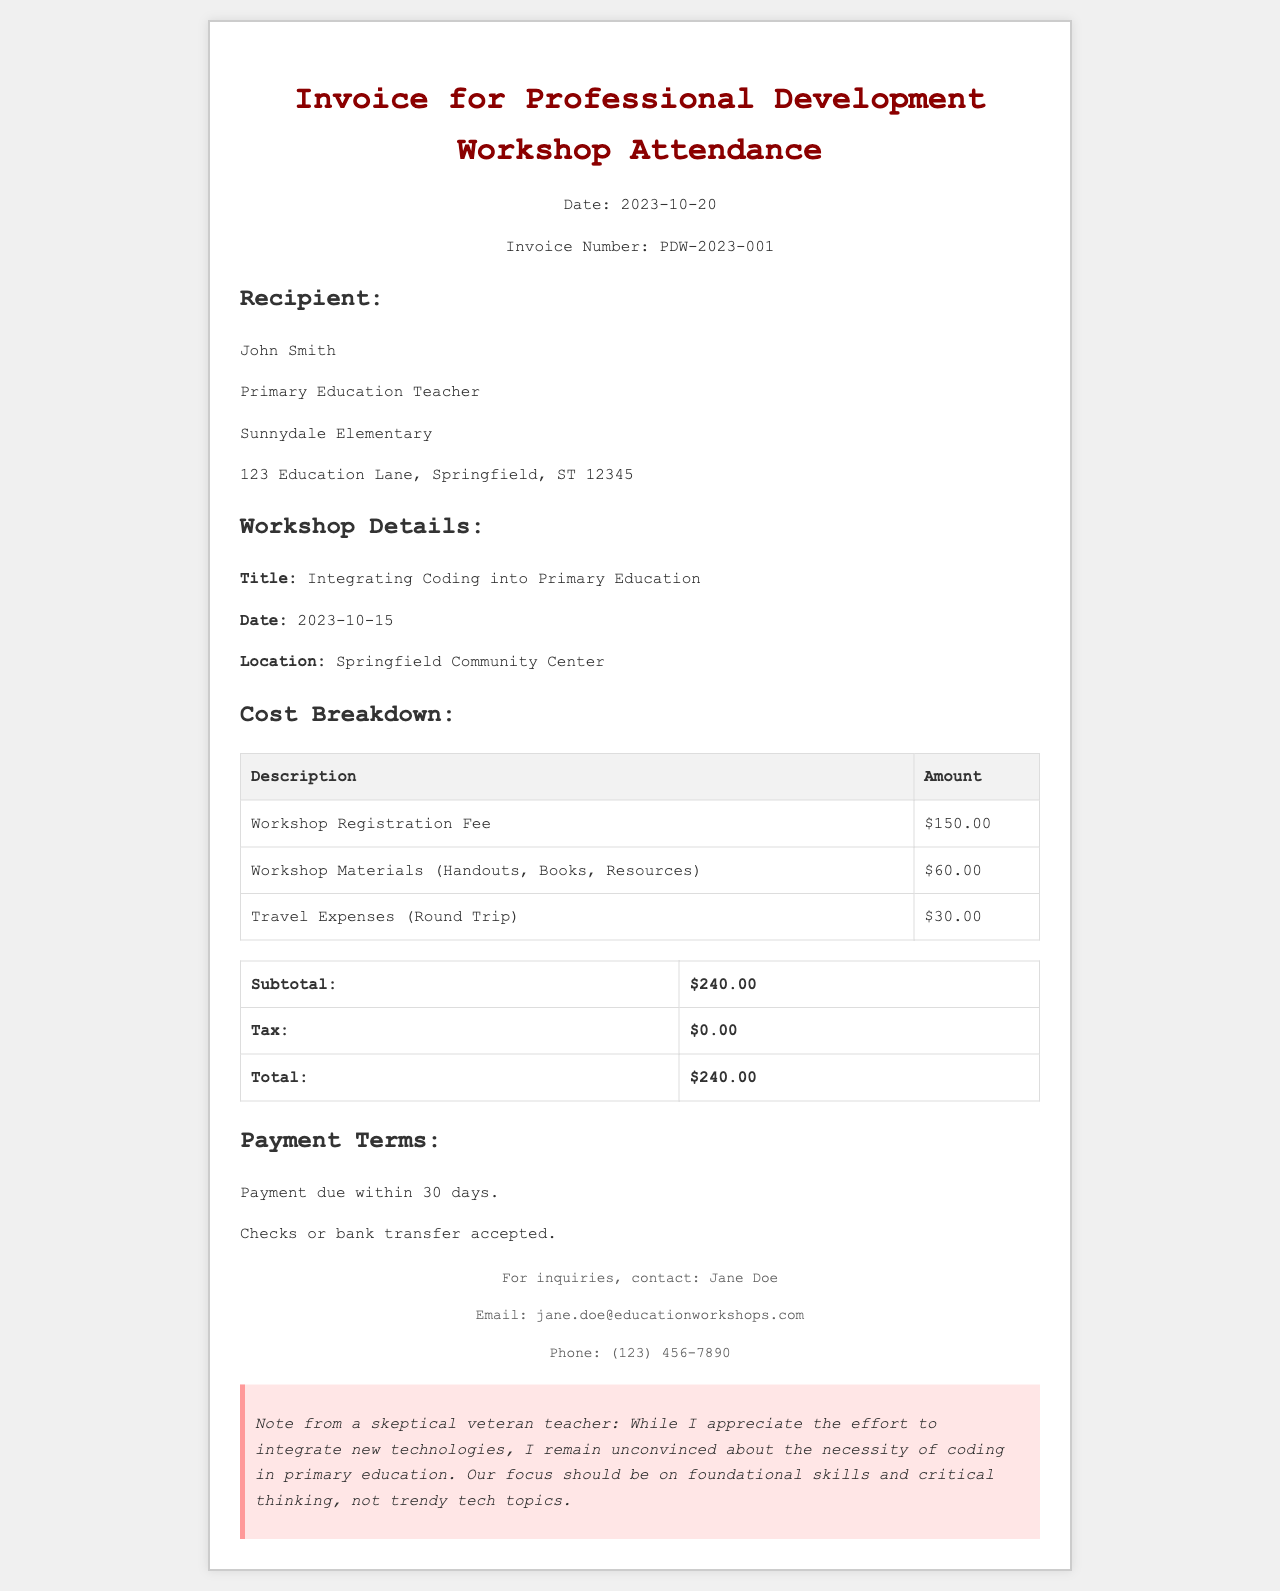What is the date of the workshop? The date of the workshop is specified in the document and is listed as October 15, 2023.
Answer: October 15, 2023 What is the invoice number? The invoice number can be found in the header section of the invoice and is listed as PDW-2023-001.
Answer: PDW-2023-001 Who is the recipient of the invoice? The document states the recipient's name, which is mentioned in the recipient section.
Answer: John Smith What is the total amount due? The total amount due is calculated based on the subtotal and is found at the end of the cost breakdown section.
Answer: $240.00 What is included in the materials cost? The materials cost refers to the items specified in the cost breakdown under workshop materials.
Answer: Handouts, Books, Resources What is the subtotal before tax? The subtotal is a specific value provided in the cost breakdown section, which represents the total before tax is added.
Answer: $240.00 What payment methods are accepted? The payment terms specify the methods of payment that are accepted in the document.
Answer: Checks or bank transfer What transportation expense is mentioned? The transportation expense is detailed in the cost breakdown of the document that indicates travel expenses.
Answer: $30.00 